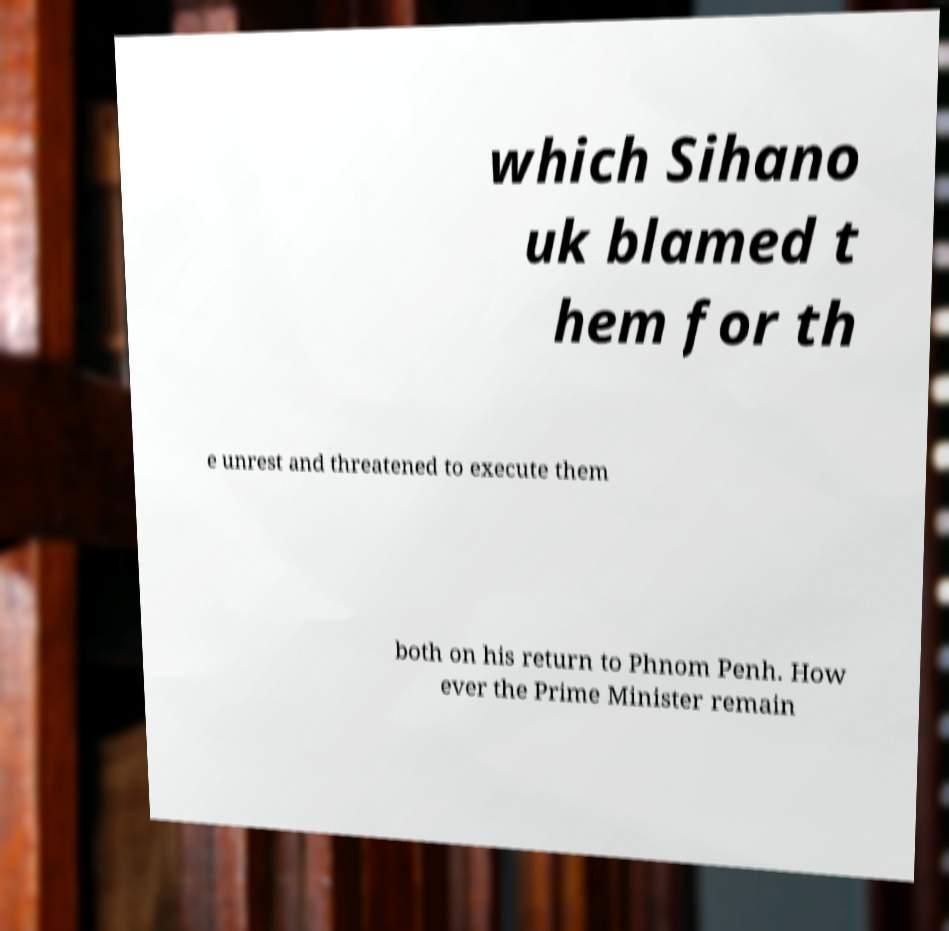I need the written content from this picture converted into text. Can you do that? which Sihano uk blamed t hem for th e unrest and threatened to execute them both on his return to Phnom Penh. How ever the Prime Minister remain 